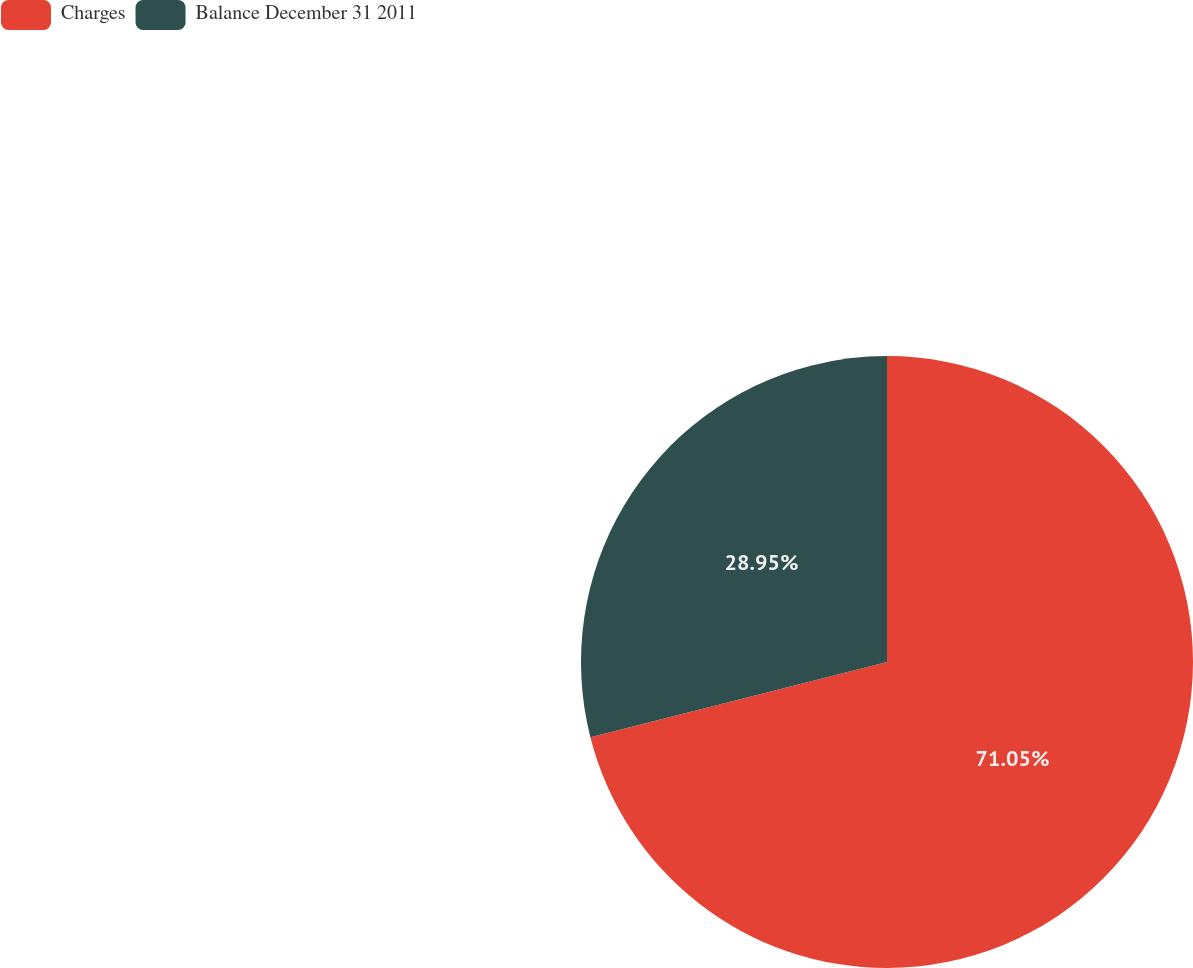Convert chart. <chart><loc_0><loc_0><loc_500><loc_500><pie_chart><fcel>Charges<fcel>Balance December 31 2011<nl><fcel>71.05%<fcel>28.95%<nl></chart> 